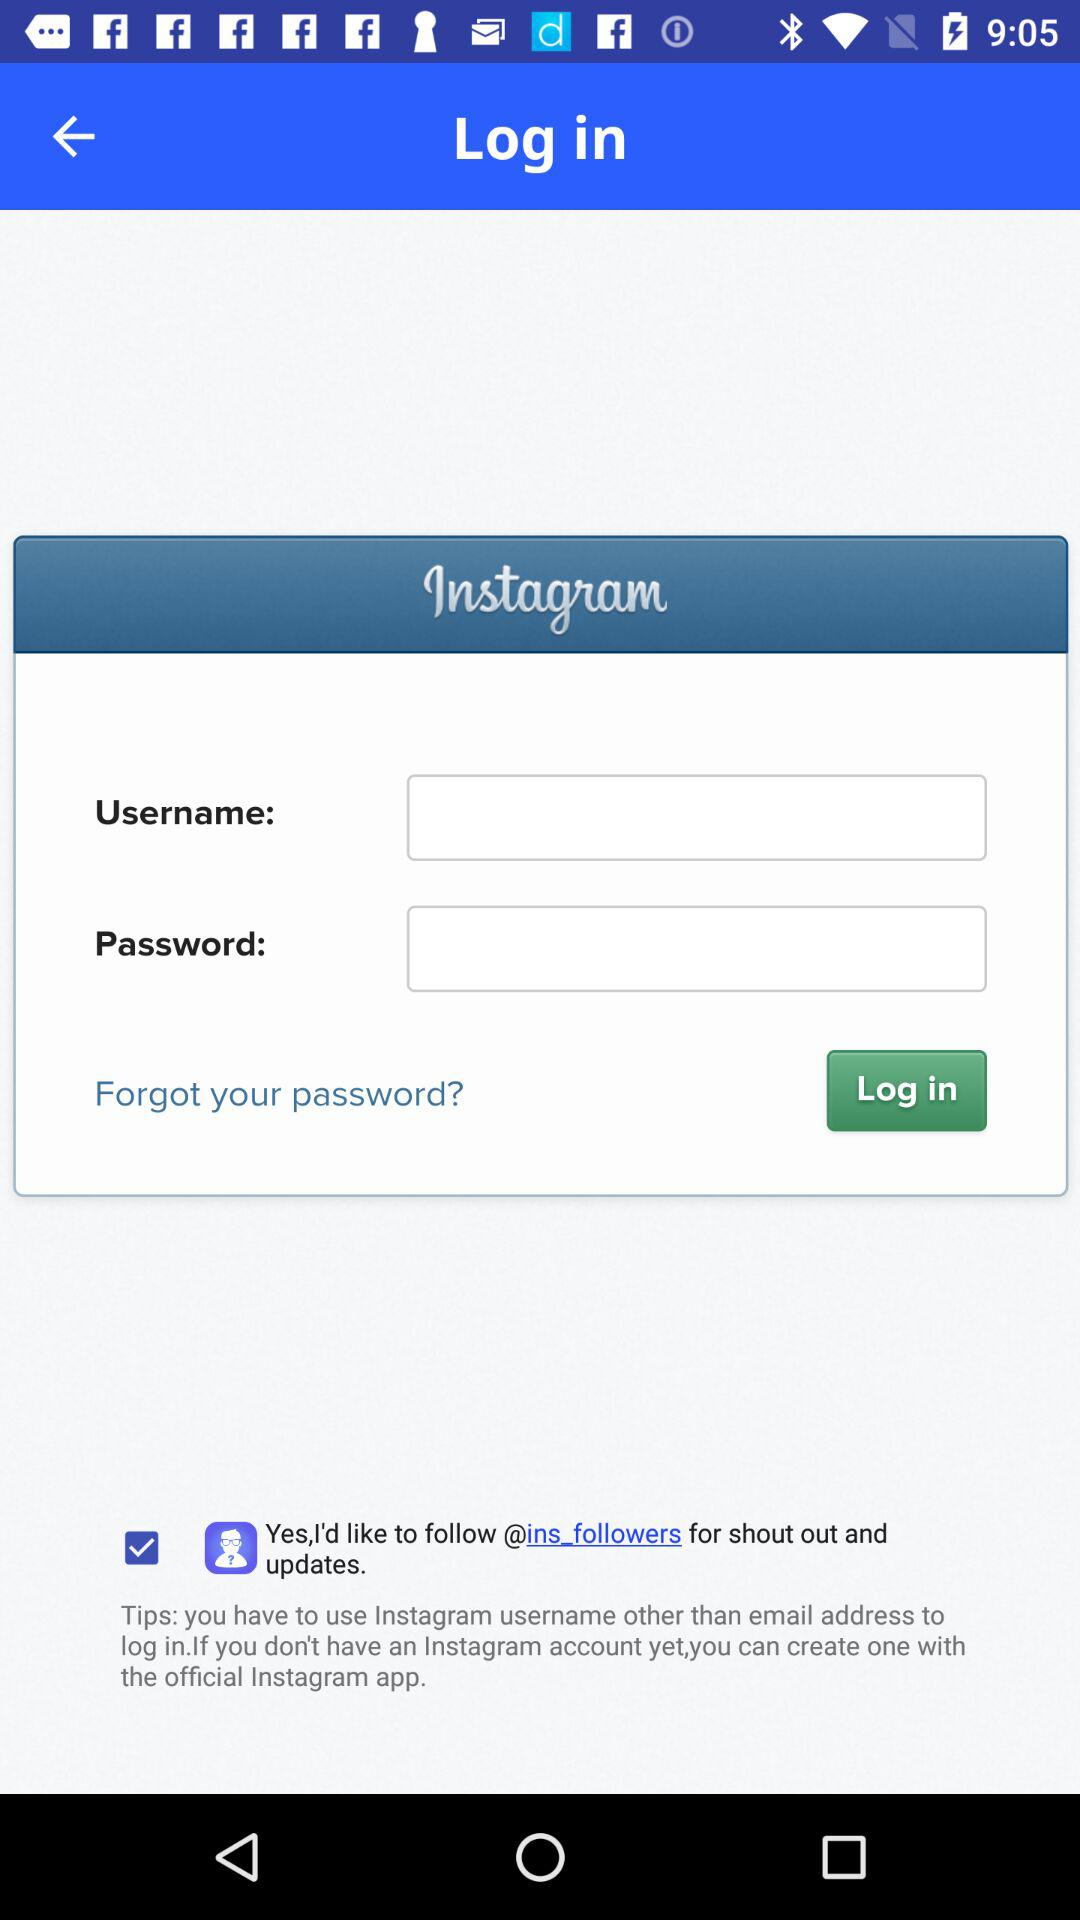How many characters are required to create a password?
When the provided information is insufficient, respond with <no answer>. <no answer> 